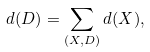Convert formula to latex. <formula><loc_0><loc_0><loc_500><loc_500>d ( D ) = \sum _ { ( X , D ) } d ( X ) ,</formula> 